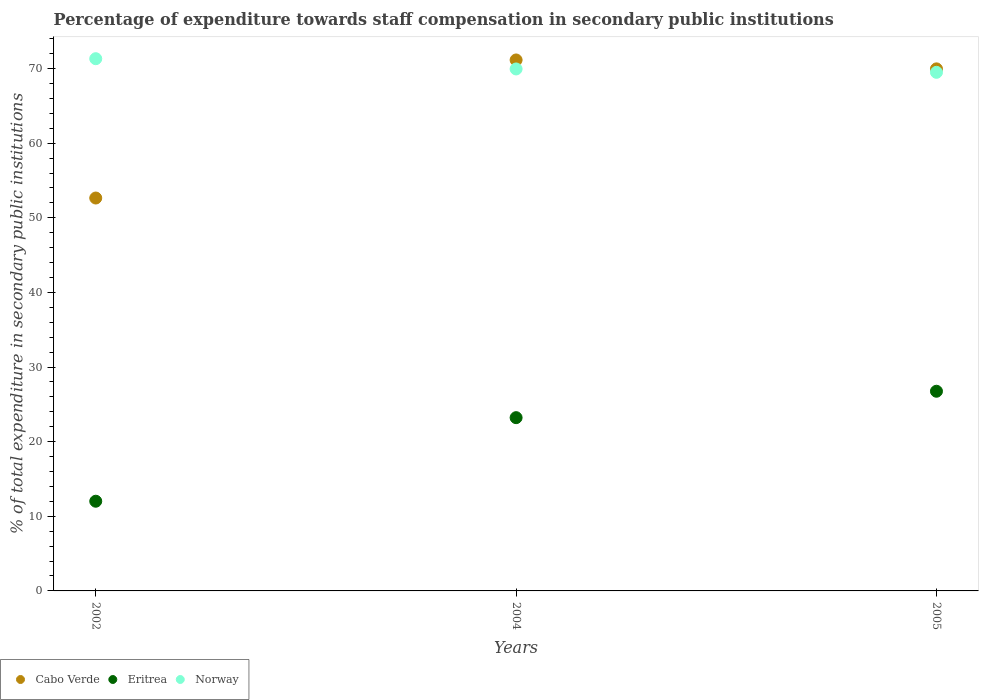How many different coloured dotlines are there?
Provide a succinct answer. 3. What is the percentage of expenditure towards staff compensation in Eritrea in 2004?
Provide a succinct answer. 23.22. Across all years, what is the maximum percentage of expenditure towards staff compensation in Norway?
Give a very brief answer. 71.32. Across all years, what is the minimum percentage of expenditure towards staff compensation in Eritrea?
Your answer should be compact. 12.02. In which year was the percentage of expenditure towards staff compensation in Norway maximum?
Your answer should be compact. 2002. In which year was the percentage of expenditure towards staff compensation in Cabo Verde minimum?
Your answer should be very brief. 2002. What is the total percentage of expenditure towards staff compensation in Eritrea in the graph?
Make the answer very short. 61.99. What is the difference between the percentage of expenditure towards staff compensation in Eritrea in 2004 and that in 2005?
Your answer should be compact. -3.54. What is the difference between the percentage of expenditure towards staff compensation in Eritrea in 2004 and the percentage of expenditure towards staff compensation in Norway in 2002?
Give a very brief answer. -48.1. What is the average percentage of expenditure towards staff compensation in Norway per year?
Your answer should be very brief. 70.25. In the year 2005, what is the difference between the percentage of expenditure towards staff compensation in Eritrea and percentage of expenditure towards staff compensation in Cabo Verde?
Make the answer very short. -43.2. What is the ratio of the percentage of expenditure towards staff compensation in Eritrea in 2002 to that in 2004?
Offer a terse response. 0.52. Is the percentage of expenditure towards staff compensation in Eritrea in 2004 less than that in 2005?
Give a very brief answer. Yes. What is the difference between the highest and the second highest percentage of expenditure towards staff compensation in Norway?
Make the answer very short. 1.37. What is the difference between the highest and the lowest percentage of expenditure towards staff compensation in Cabo Verde?
Provide a succinct answer. 18.5. In how many years, is the percentage of expenditure towards staff compensation in Norway greater than the average percentage of expenditure towards staff compensation in Norway taken over all years?
Your answer should be compact. 1. Is it the case that in every year, the sum of the percentage of expenditure towards staff compensation in Eritrea and percentage of expenditure towards staff compensation in Norway  is greater than the percentage of expenditure towards staff compensation in Cabo Verde?
Provide a succinct answer. Yes. Is the percentage of expenditure towards staff compensation in Cabo Verde strictly greater than the percentage of expenditure towards staff compensation in Eritrea over the years?
Your answer should be very brief. Yes. Is the percentage of expenditure towards staff compensation in Norway strictly less than the percentage of expenditure towards staff compensation in Cabo Verde over the years?
Ensure brevity in your answer.  No. How many dotlines are there?
Keep it short and to the point. 3. How many years are there in the graph?
Provide a succinct answer. 3. Are the values on the major ticks of Y-axis written in scientific E-notation?
Your answer should be compact. No. Where does the legend appear in the graph?
Offer a very short reply. Bottom left. How many legend labels are there?
Offer a terse response. 3. What is the title of the graph?
Your answer should be very brief. Percentage of expenditure towards staff compensation in secondary public institutions. Does "North America" appear as one of the legend labels in the graph?
Provide a short and direct response. No. What is the label or title of the X-axis?
Ensure brevity in your answer.  Years. What is the label or title of the Y-axis?
Offer a very short reply. % of total expenditure in secondary public institutions. What is the % of total expenditure in secondary public institutions in Cabo Verde in 2002?
Your response must be concise. 52.65. What is the % of total expenditure in secondary public institutions of Eritrea in 2002?
Your response must be concise. 12.02. What is the % of total expenditure in secondary public institutions of Norway in 2002?
Make the answer very short. 71.32. What is the % of total expenditure in secondary public institutions in Cabo Verde in 2004?
Provide a succinct answer. 71.15. What is the % of total expenditure in secondary public institutions of Eritrea in 2004?
Your response must be concise. 23.22. What is the % of total expenditure in secondary public institutions in Norway in 2004?
Make the answer very short. 69.95. What is the % of total expenditure in secondary public institutions of Cabo Verde in 2005?
Your answer should be compact. 69.96. What is the % of total expenditure in secondary public institutions of Eritrea in 2005?
Offer a very short reply. 26.76. What is the % of total expenditure in secondary public institutions of Norway in 2005?
Your answer should be compact. 69.49. Across all years, what is the maximum % of total expenditure in secondary public institutions in Cabo Verde?
Keep it short and to the point. 71.15. Across all years, what is the maximum % of total expenditure in secondary public institutions of Eritrea?
Your answer should be very brief. 26.76. Across all years, what is the maximum % of total expenditure in secondary public institutions of Norway?
Your answer should be very brief. 71.32. Across all years, what is the minimum % of total expenditure in secondary public institutions of Cabo Verde?
Give a very brief answer. 52.65. Across all years, what is the minimum % of total expenditure in secondary public institutions in Eritrea?
Ensure brevity in your answer.  12.02. Across all years, what is the minimum % of total expenditure in secondary public institutions of Norway?
Keep it short and to the point. 69.49. What is the total % of total expenditure in secondary public institutions in Cabo Verde in the graph?
Your response must be concise. 193.76. What is the total % of total expenditure in secondary public institutions of Eritrea in the graph?
Provide a succinct answer. 61.99. What is the total % of total expenditure in secondary public institutions in Norway in the graph?
Your response must be concise. 210.76. What is the difference between the % of total expenditure in secondary public institutions of Cabo Verde in 2002 and that in 2004?
Provide a succinct answer. -18.5. What is the difference between the % of total expenditure in secondary public institutions of Eritrea in 2002 and that in 2004?
Provide a succinct answer. -11.2. What is the difference between the % of total expenditure in secondary public institutions of Norway in 2002 and that in 2004?
Keep it short and to the point. 1.37. What is the difference between the % of total expenditure in secondary public institutions in Cabo Verde in 2002 and that in 2005?
Your response must be concise. -17.31. What is the difference between the % of total expenditure in secondary public institutions of Eritrea in 2002 and that in 2005?
Your response must be concise. -14.74. What is the difference between the % of total expenditure in secondary public institutions of Norway in 2002 and that in 2005?
Give a very brief answer. 1.83. What is the difference between the % of total expenditure in secondary public institutions of Cabo Verde in 2004 and that in 2005?
Offer a very short reply. 1.19. What is the difference between the % of total expenditure in secondary public institutions of Eritrea in 2004 and that in 2005?
Give a very brief answer. -3.54. What is the difference between the % of total expenditure in secondary public institutions of Norway in 2004 and that in 2005?
Keep it short and to the point. 0.45. What is the difference between the % of total expenditure in secondary public institutions in Cabo Verde in 2002 and the % of total expenditure in secondary public institutions in Eritrea in 2004?
Your answer should be compact. 29.43. What is the difference between the % of total expenditure in secondary public institutions of Cabo Verde in 2002 and the % of total expenditure in secondary public institutions of Norway in 2004?
Offer a very short reply. -17.3. What is the difference between the % of total expenditure in secondary public institutions of Eritrea in 2002 and the % of total expenditure in secondary public institutions of Norway in 2004?
Your answer should be compact. -57.93. What is the difference between the % of total expenditure in secondary public institutions of Cabo Verde in 2002 and the % of total expenditure in secondary public institutions of Eritrea in 2005?
Your answer should be very brief. 25.89. What is the difference between the % of total expenditure in secondary public institutions of Cabo Verde in 2002 and the % of total expenditure in secondary public institutions of Norway in 2005?
Your answer should be compact. -16.84. What is the difference between the % of total expenditure in secondary public institutions of Eritrea in 2002 and the % of total expenditure in secondary public institutions of Norway in 2005?
Your answer should be very brief. -57.48. What is the difference between the % of total expenditure in secondary public institutions in Cabo Verde in 2004 and the % of total expenditure in secondary public institutions in Eritrea in 2005?
Offer a terse response. 44.39. What is the difference between the % of total expenditure in secondary public institutions in Cabo Verde in 2004 and the % of total expenditure in secondary public institutions in Norway in 2005?
Your response must be concise. 1.66. What is the difference between the % of total expenditure in secondary public institutions in Eritrea in 2004 and the % of total expenditure in secondary public institutions in Norway in 2005?
Give a very brief answer. -46.28. What is the average % of total expenditure in secondary public institutions in Cabo Verde per year?
Provide a short and direct response. 64.59. What is the average % of total expenditure in secondary public institutions in Eritrea per year?
Give a very brief answer. 20.66. What is the average % of total expenditure in secondary public institutions of Norway per year?
Ensure brevity in your answer.  70.25. In the year 2002, what is the difference between the % of total expenditure in secondary public institutions in Cabo Verde and % of total expenditure in secondary public institutions in Eritrea?
Offer a very short reply. 40.63. In the year 2002, what is the difference between the % of total expenditure in secondary public institutions of Cabo Verde and % of total expenditure in secondary public institutions of Norway?
Your answer should be very brief. -18.67. In the year 2002, what is the difference between the % of total expenditure in secondary public institutions in Eritrea and % of total expenditure in secondary public institutions in Norway?
Your answer should be compact. -59.3. In the year 2004, what is the difference between the % of total expenditure in secondary public institutions in Cabo Verde and % of total expenditure in secondary public institutions in Eritrea?
Offer a very short reply. 47.93. In the year 2004, what is the difference between the % of total expenditure in secondary public institutions of Cabo Verde and % of total expenditure in secondary public institutions of Norway?
Offer a very short reply. 1.2. In the year 2004, what is the difference between the % of total expenditure in secondary public institutions in Eritrea and % of total expenditure in secondary public institutions in Norway?
Offer a very short reply. -46.73. In the year 2005, what is the difference between the % of total expenditure in secondary public institutions in Cabo Verde and % of total expenditure in secondary public institutions in Eritrea?
Give a very brief answer. 43.2. In the year 2005, what is the difference between the % of total expenditure in secondary public institutions of Cabo Verde and % of total expenditure in secondary public institutions of Norway?
Offer a very short reply. 0.46. In the year 2005, what is the difference between the % of total expenditure in secondary public institutions of Eritrea and % of total expenditure in secondary public institutions of Norway?
Offer a very short reply. -42.74. What is the ratio of the % of total expenditure in secondary public institutions in Cabo Verde in 2002 to that in 2004?
Offer a very short reply. 0.74. What is the ratio of the % of total expenditure in secondary public institutions of Eritrea in 2002 to that in 2004?
Provide a succinct answer. 0.52. What is the ratio of the % of total expenditure in secondary public institutions of Norway in 2002 to that in 2004?
Ensure brevity in your answer.  1.02. What is the ratio of the % of total expenditure in secondary public institutions in Cabo Verde in 2002 to that in 2005?
Keep it short and to the point. 0.75. What is the ratio of the % of total expenditure in secondary public institutions of Eritrea in 2002 to that in 2005?
Make the answer very short. 0.45. What is the ratio of the % of total expenditure in secondary public institutions of Norway in 2002 to that in 2005?
Offer a terse response. 1.03. What is the ratio of the % of total expenditure in secondary public institutions in Cabo Verde in 2004 to that in 2005?
Make the answer very short. 1.02. What is the ratio of the % of total expenditure in secondary public institutions of Eritrea in 2004 to that in 2005?
Your response must be concise. 0.87. What is the difference between the highest and the second highest % of total expenditure in secondary public institutions in Cabo Verde?
Your answer should be very brief. 1.19. What is the difference between the highest and the second highest % of total expenditure in secondary public institutions of Eritrea?
Offer a very short reply. 3.54. What is the difference between the highest and the second highest % of total expenditure in secondary public institutions of Norway?
Ensure brevity in your answer.  1.37. What is the difference between the highest and the lowest % of total expenditure in secondary public institutions of Cabo Verde?
Your response must be concise. 18.5. What is the difference between the highest and the lowest % of total expenditure in secondary public institutions of Eritrea?
Your response must be concise. 14.74. What is the difference between the highest and the lowest % of total expenditure in secondary public institutions of Norway?
Your answer should be compact. 1.83. 